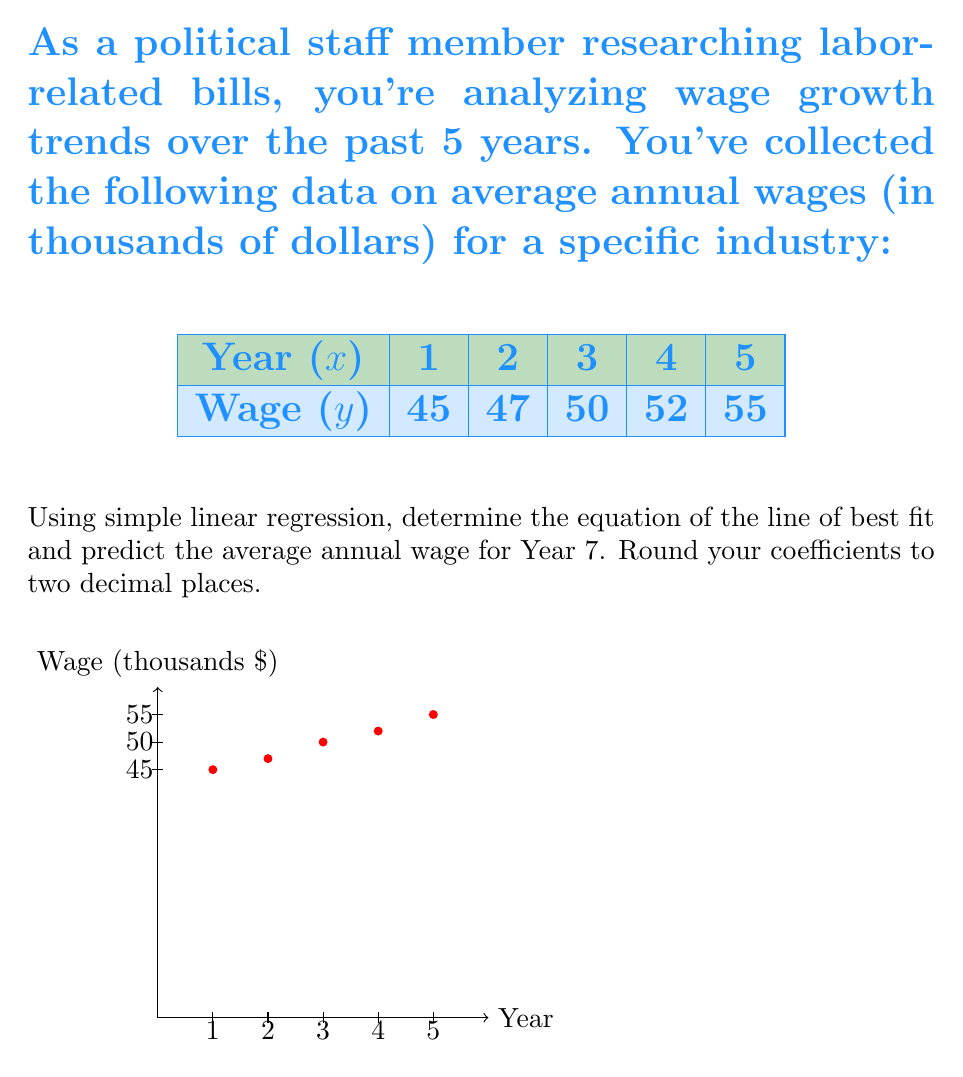Solve this math problem. To solve this problem, we'll use the simple linear regression formula:

$$y = mx + b$$

Where $m$ is the slope and $b$ is the y-intercept.

Step 1: Calculate the means of $x$ and $y$
$$\bar{x} = \frac{1+2+3+4+5}{5} = 3$$
$$\bar{y} = \frac{45+47+50+52+55}{5} = 49.8$$

Step 2: Calculate the slope $m$
$$m = \frac{\sum(x_i - \bar{x})(y_i - \bar{y})}{\sum(x_i - \bar{x})^2}$$

Create a table to calculate the numerator and denominator:

$x_i$ | $y_i$ | $x_i - \bar{x}$ | $y_i - \bar{y}$ | $(x_i - \bar{x})(y_i - \bar{y})$ | $(x_i - \bar{x})^2$
1 | 45 | -2 | -4.8 | 9.6 | 4
2 | 47 | -1 | -2.8 | 2.8 | 1
3 | 50 | 0 | 0.2 | 0 | 0
4 | 52 | 1 | 2.2 | 2.2 | 1
5 | 55 | 2 | 5.2 | 10.4 | 4

Sum the last two columns:
$$\sum(x_i - \bar{x})(y_i - \bar{y}) = 25$$
$$\sum(x_i - \bar{x})^2 = 10$$

$$m = \frac{25}{10} = 2.5$$

Step 3: Calculate the y-intercept $b$
$$b = \bar{y} - m\bar{x} = 49.8 - 2.5(3) = 42.3$$

Step 4: Write the equation of the line of best fit
$$y = 2.50x + 42.30$$

Step 5: Predict the wage for Year 7
$$y = 2.50(7) + 42.30 = 59.80$$

Therefore, the predicted average annual wage for Year 7 is $59,800.
Answer: $y = 2.50x + 42.30$; $59,800 